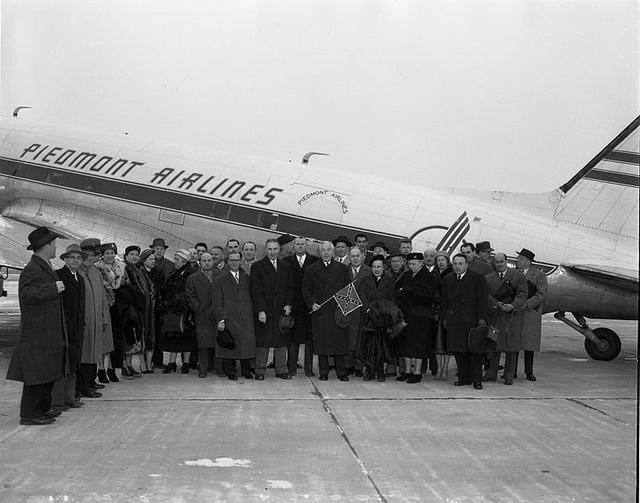How many people can you see?
Give a very brief answer. 11. How many glass cups have water in them?
Give a very brief answer. 0. 